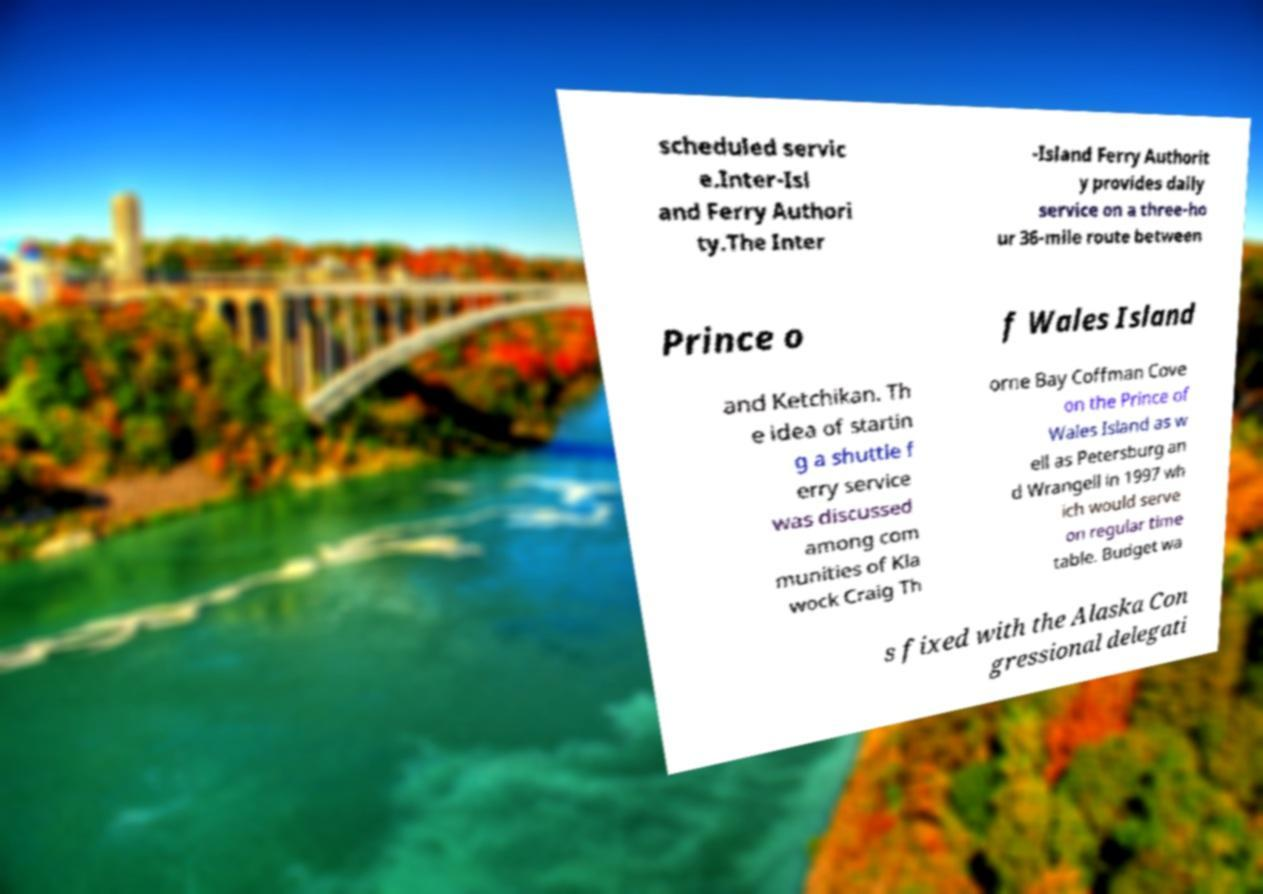Could you extract and type out the text from this image? scheduled servic e.Inter-Isl and Ferry Authori ty.The Inter -Island Ferry Authorit y provides daily service on a three-ho ur 36-mile route between Prince o f Wales Island and Ketchikan. Th e idea of startin g a shuttle f erry service was discussed among com munities of Kla wock Craig Th orne Bay Coffman Cove on the Prince of Wales Island as w ell as Petersburg an d Wrangell in 1997 wh ich would serve on regular time table. Budget wa s fixed with the Alaska Con gressional delegati 